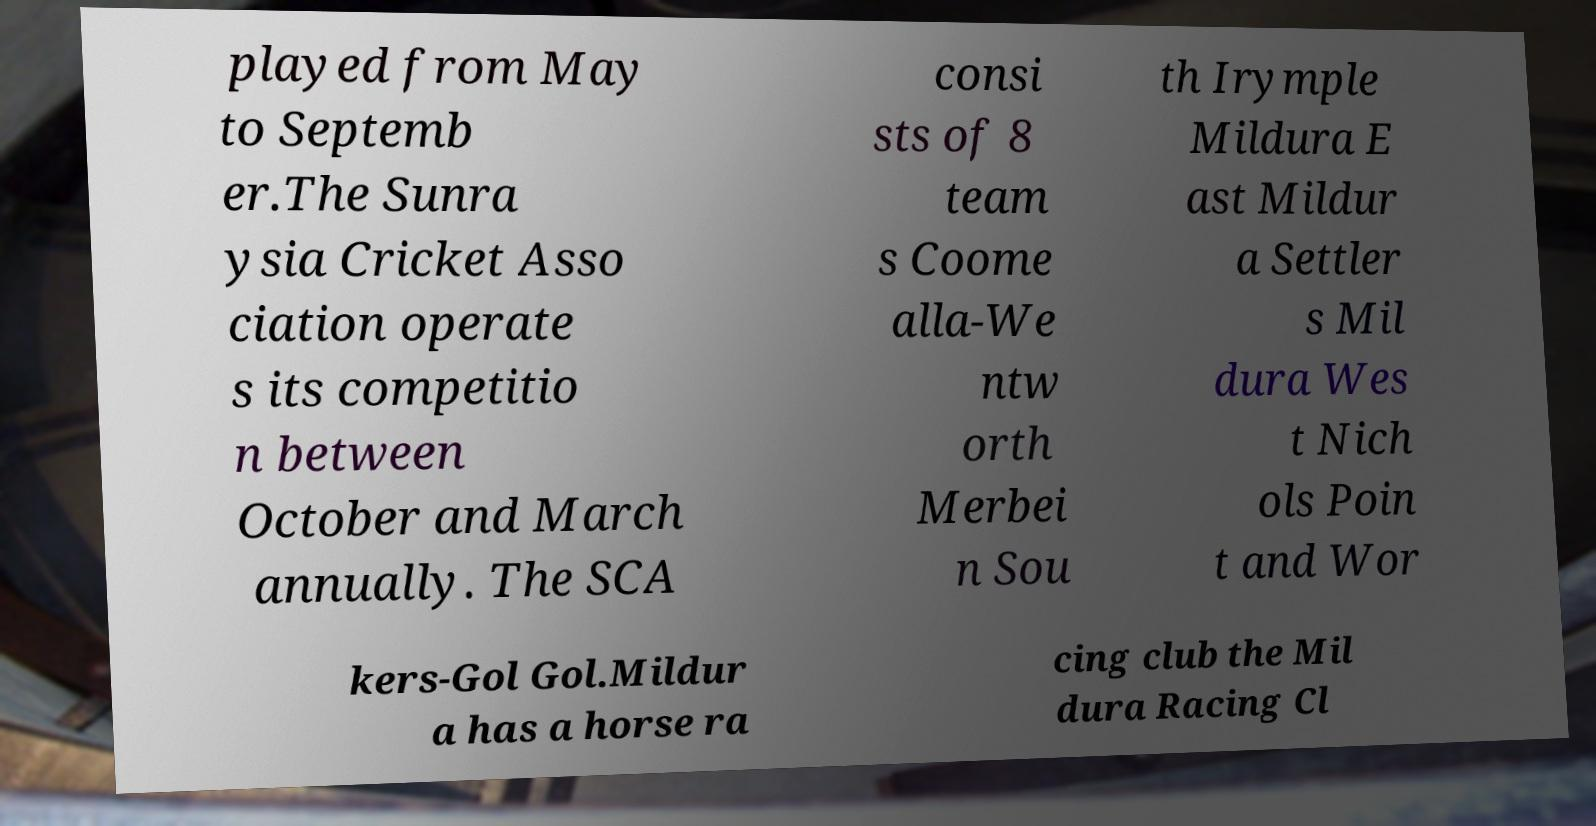There's text embedded in this image that I need extracted. Can you transcribe it verbatim? played from May to Septemb er.The Sunra ysia Cricket Asso ciation operate s its competitio n between October and March annually. The SCA consi sts of 8 team s Coome alla-We ntw orth Merbei n Sou th Irymple Mildura E ast Mildur a Settler s Mil dura Wes t Nich ols Poin t and Wor kers-Gol Gol.Mildur a has a horse ra cing club the Mil dura Racing Cl 